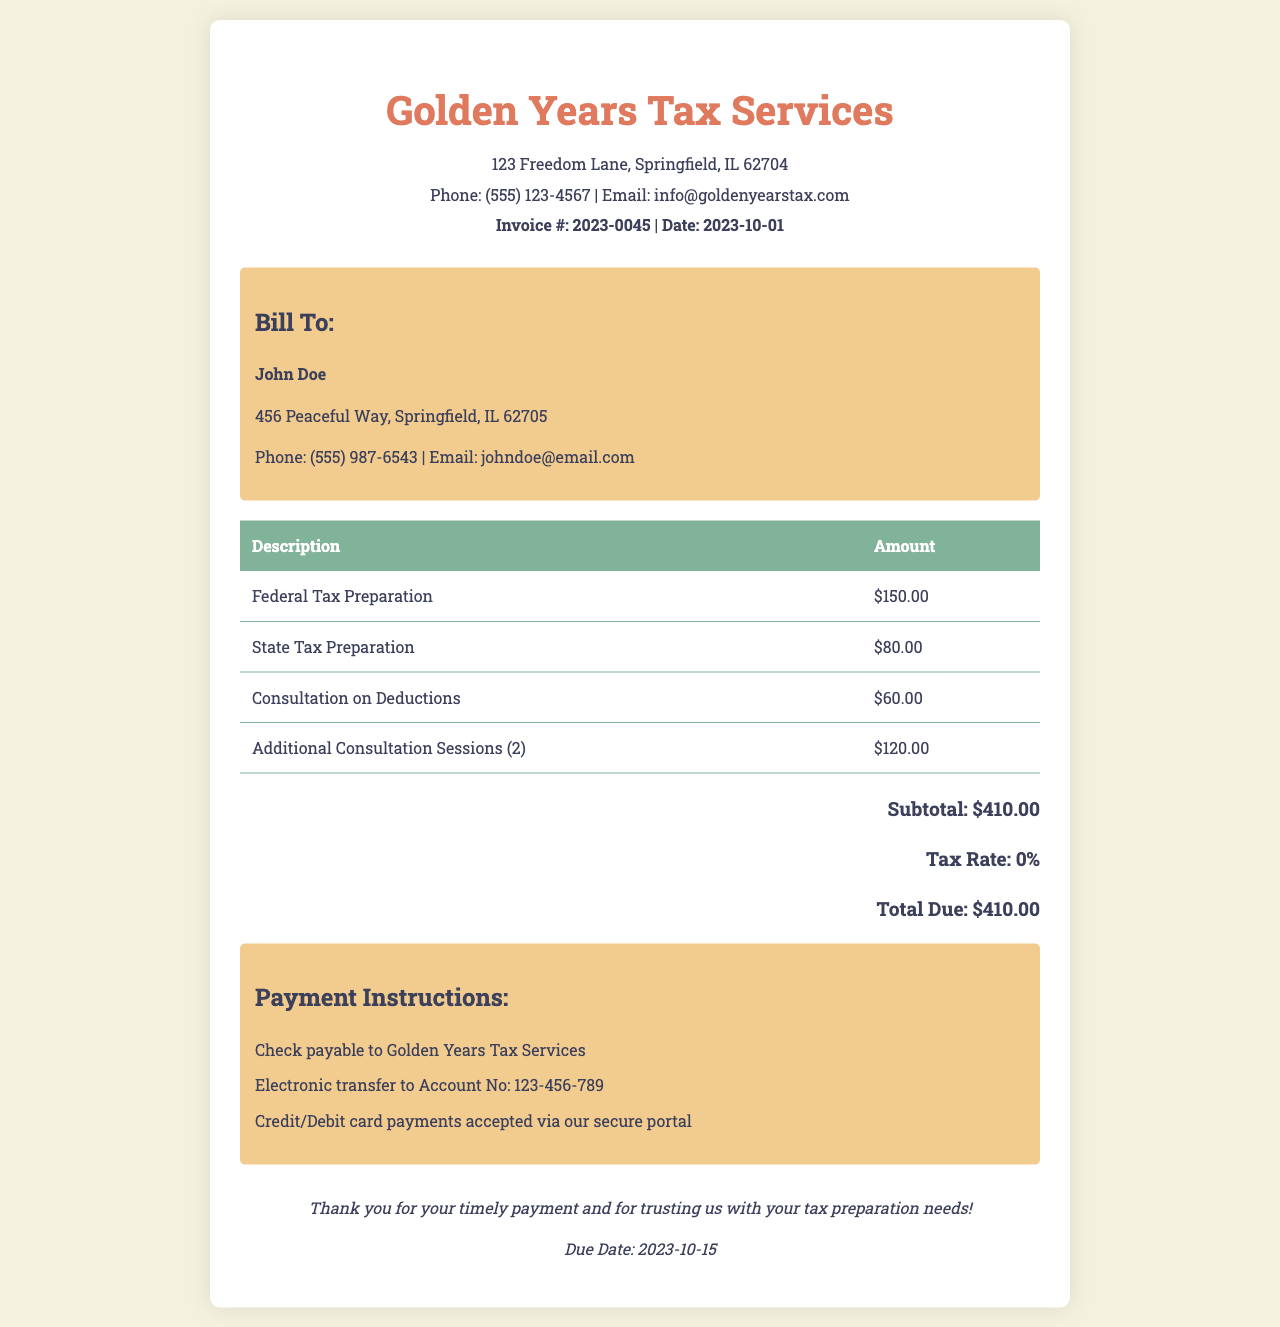What is the total due? The total due is the final amount that needs to be paid, which is listed at the bottom of the invoice.
Answer: $410.00 Who is the invoice billed to? The person or entity to whom the invoice is directed is listed in the client info section.
Answer: John Doe How much is the fee for state tax preparation? The fee for state tax preparation is one of the line items in the table of services rendered.
Answer: $80.00 What date is the invoice issued? The date of the invoice is located near the invoice number.
Answer: 2023-10-01 How many additional consultation sessions were included? The invoice specifies the number of additional consultation sessions in one of the itemized descriptions.
Answer: 2 What payment methods are accepted? The section outlines available methods for making payment, which are specified after the total.
Answer: Check, Electronic transfer, Credit/Debit card What is the address of Golden Years Tax Services? The address is provided in the header section of the invoice.
Answer: 123 Freedom Lane, Springfield, IL 62704 What is the due date for payment? The due date is mentioned in the footer of the invoice, indicating when payment must be made.
Answer: 2023-10-15 What is the subtotal before tax? The subtotal represents the sum of all charges before any applicable taxes, as indicated in the total section.
Answer: $410.00 